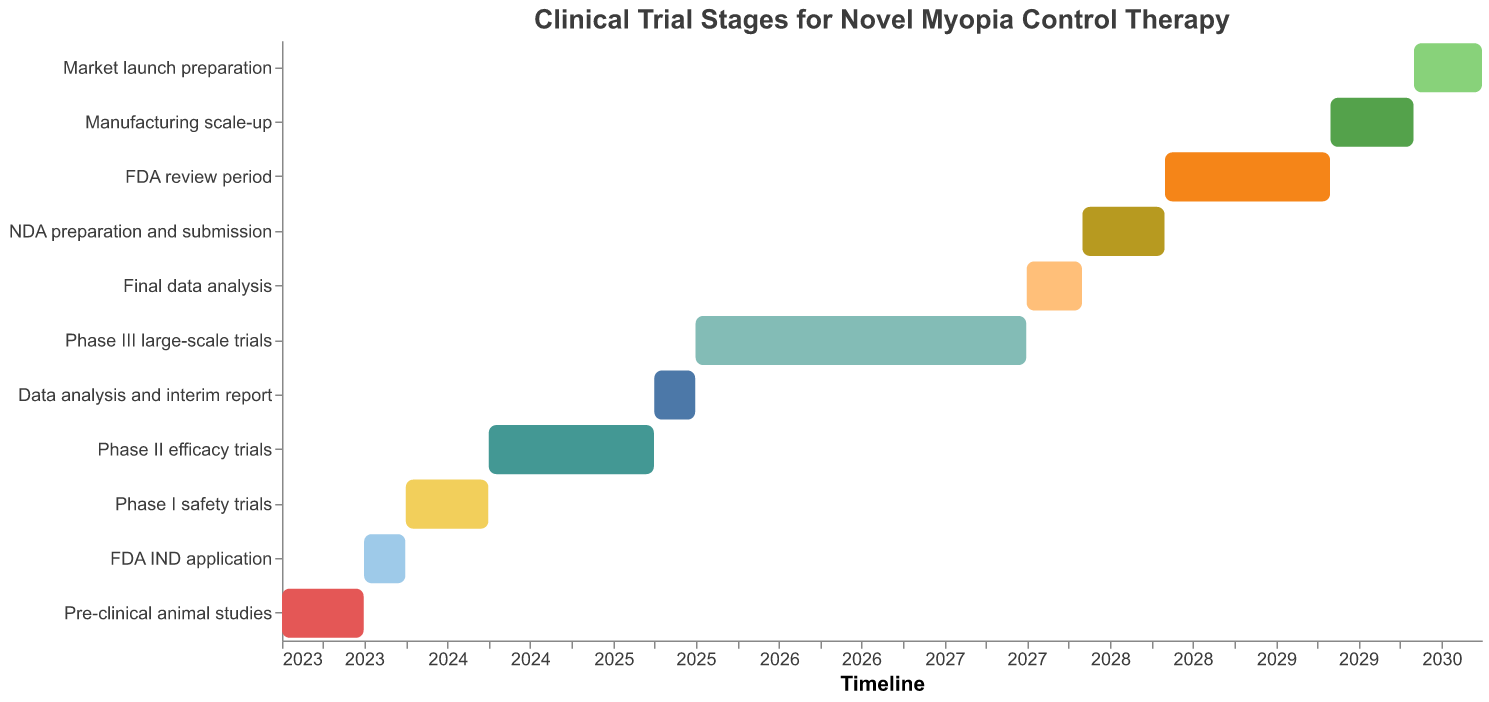What's the title of the figure? The title can be found at the top of the figure which is usually in larger font and centered.
Answer: Clinical Trial Stages for Novel Myopia Control Therapy When does the Pre-clinical animal studies stage start and end? Look for the bar labeled "Pre-clinical animal studies". The start date is at the beginning of the bar, and the end date is at the end of the bar in the tooltip.
Answer: January 2023 - June 2023 How long is the Phase II efficacy trials stage? Look at the bar labeled "Phase II efficacy trials" and calculate the difference between the end date and the start date.
Answer: 1 year Which stage comes immediately after the "Phase III large-scale trials" stage? Identify the bar for "Phase III large-scale trials", then find the next bar in the timeline.
Answer: Final data analysis Identify the stages that start in 2027. Look for all bars that have their start dates in the year 2027.
Answer: Final data analysis, NDA preparation and submission How many stages are there in total? Count all the bars in the Gantt chart, each representing a stage.
Answer: 11 Which stage lasts the longest, and how long is it? Compare the lengths of all bars by looking from the start to the end dates.
Answer: Phase III large-scale trials, 2 years What is the duration of the entire clinical trial process? Find the duration from the start date of the first stage to the end date of the last stage.
Answer: 7 years and 3 months Which stage overlaps with the "FDA review period"? Identify the "FDA review period" bar, then see which stages' bars overlap during this period.
Answer: Manufacturing scale-up How much time is there between the end of "Final data analysis" and the start of "FDA review period"? Calculate the difference between the end date of "Final data analysis" and the start date of "FDA review period".
Answer: 1 day 